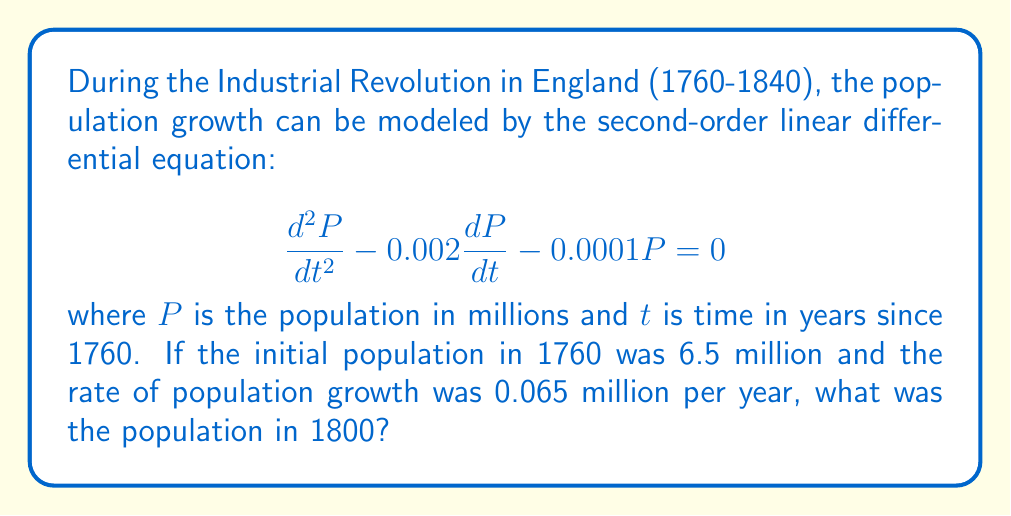Can you answer this question? To solve this problem, we'll follow these steps:

1) The general solution for this second-order linear differential equation is:
   $$P(t) = C_1e^{r_1t} + C_2e^{r_2t}$$
   where $r_1$ and $r_2$ are roots of the characteristic equation.

2) The characteristic equation is:
   $$r^2 - 0.002r - 0.0001 = 0$$

3) Solving this quadratic equation:
   $$r = \frac{0.002 \pm \sqrt{0.002^2 + 4(0.0001)}}{2} = 0.01 \text{ or } -0.008$$

4) Thus, the general solution is:
   $$P(t) = C_1e^{0.01t} + C_2e^{-0.008t}$$

5) We use the initial conditions to find $C_1$ and $C_2$:
   At $t=0$: $P(0) = 6.5 = C_1 + C_2$
   $\frac{dP}{dt}(0) = 0.065 = 0.01C_1 - 0.008C_2$

6) Solving these equations:
   $C_1 \approx 7.361$ and $C_2 \approx -0.861$

7) Therefore, the particular solution is:
   $$P(t) = 7.361e^{0.01t} - 0.861e^{-0.008t}$$

8) To find the population in 1800, we calculate $P(40)$:
   $$P(40) = 7.361e^{0.4} - 0.861e^{-0.32} \approx 9.224$$
Answer: 9.224 million 